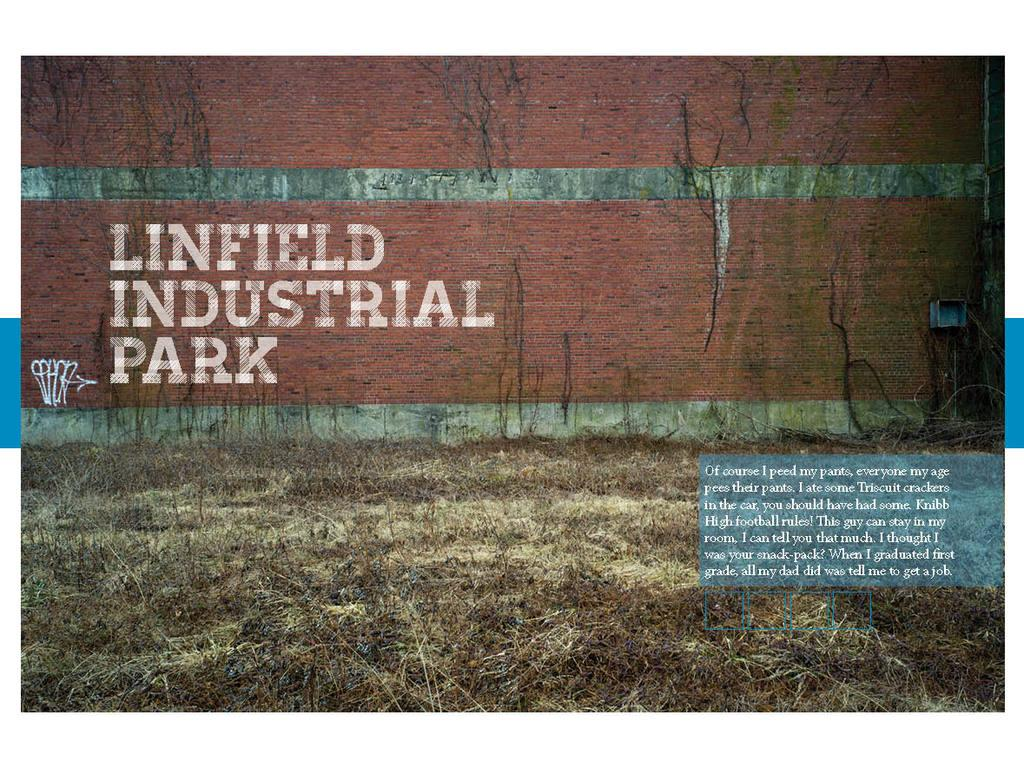What is present in the image that serves as a background? There is a wall in the image that serves as a background. What is written or depicted on the wall? There is text on the wall. What type of vegetation can be seen on the ground in the image? There is dry grass on the ground at the bottom of the image. What type of bone can be seen sticking out of the wall in the image? There is no bone present in the image; it only features a wall with text and dry grass on the ground. 